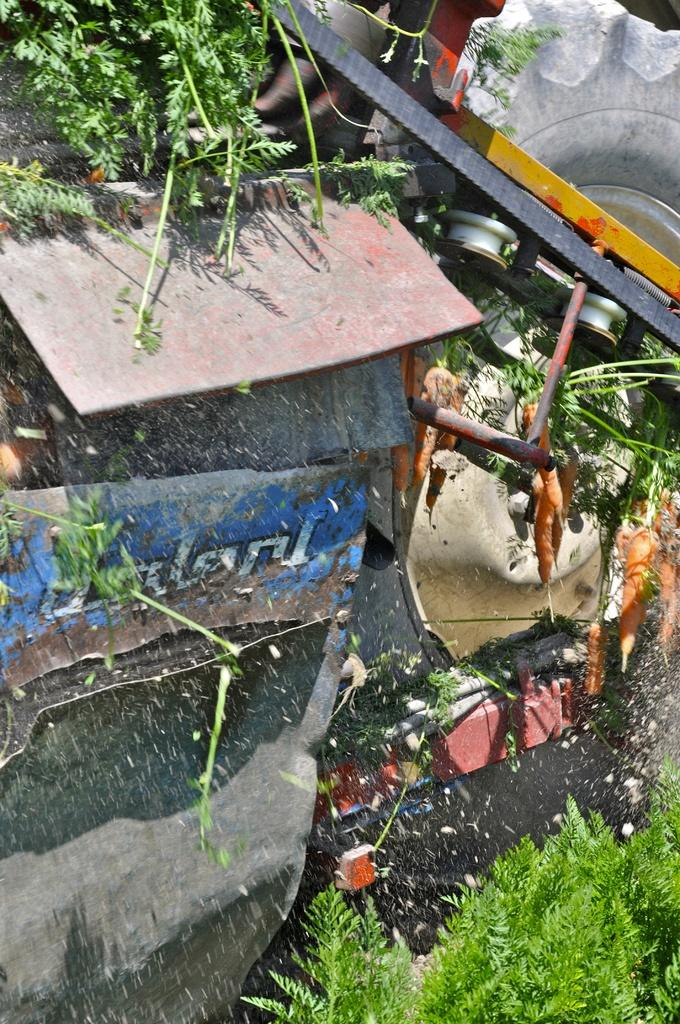What type of plant is in the image? The plant in the image is green. What can be seen in the background of the image? There is a hut in the background of the image. What object is located on the left side of the image? There is a wheel on the left side of the image. What colors are present in the image besides green? There are objects in yellow and gray colors in the image. What type of breakfast does the plant's owner serve in the image? There is no indication of an owner or breakfast in the image; it features a green plant, a hut in the background, a wheel on the left side, and objects in yellow and gray colors. 